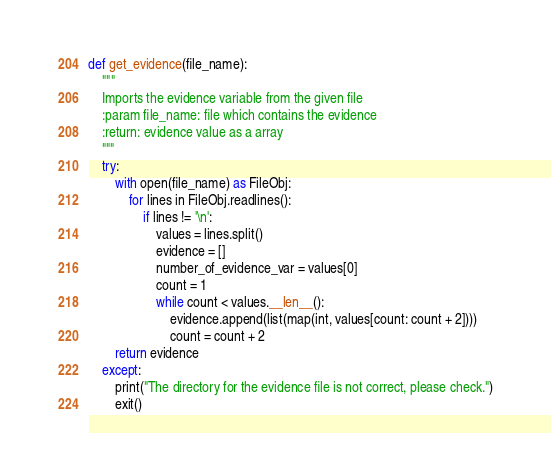<code> <loc_0><loc_0><loc_500><loc_500><_Python_>def get_evidence(file_name):
    """
    Imports the evidence variable from the given file
    :param file_name: file which contains the evidence
    :return: evidence value as a array
    """
    try:
        with open(file_name) as FileObj:
            for lines in FileObj.readlines():
                if lines != '\n':
                    values = lines.split()
                    evidence = []
                    number_of_evidence_var = values[0]
                    count = 1
                    while count < values.__len__():
                        evidence.append(list(map(int, values[count: count + 2])))
                        count = count + 2
        return evidence
    except:
        print("The directory for the evidence file is not correct, please check.")
        exit()</code> 